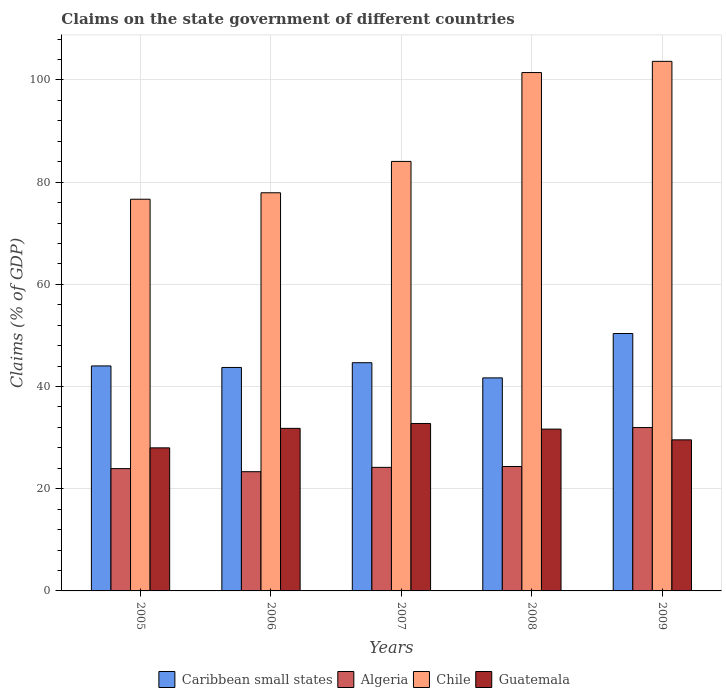How many different coloured bars are there?
Give a very brief answer. 4. How many groups of bars are there?
Your response must be concise. 5. How many bars are there on the 3rd tick from the left?
Your answer should be very brief. 4. How many bars are there on the 2nd tick from the right?
Keep it short and to the point. 4. In how many cases, is the number of bars for a given year not equal to the number of legend labels?
Provide a succinct answer. 0. What is the percentage of GDP claimed on the state government in Guatemala in 2006?
Provide a succinct answer. 31.82. Across all years, what is the maximum percentage of GDP claimed on the state government in Caribbean small states?
Offer a very short reply. 50.38. Across all years, what is the minimum percentage of GDP claimed on the state government in Caribbean small states?
Provide a short and direct response. 41.7. In which year was the percentage of GDP claimed on the state government in Caribbean small states maximum?
Offer a terse response. 2009. What is the total percentage of GDP claimed on the state government in Chile in the graph?
Offer a very short reply. 443.74. What is the difference between the percentage of GDP claimed on the state government in Guatemala in 2006 and that in 2008?
Provide a short and direct response. 0.15. What is the difference between the percentage of GDP claimed on the state government in Algeria in 2007 and the percentage of GDP claimed on the state government in Chile in 2009?
Your answer should be very brief. -79.46. What is the average percentage of GDP claimed on the state government in Chile per year?
Offer a very short reply. 88.75. In the year 2008, what is the difference between the percentage of GDP claimed on the state government in Caribbean small states and percentage of GDP claimed on the state government in Algeria?
Your response must be concise. 17.34. What is the ratio of the percentage of GDP claimed on the state government in Algeria in 2008 to that in 2009?
Your response must be concise. 0.76. Is the difference between the percentage of GDP claimed on the state government in Caribbean small states in 2005 and 2006 greater than the difference between the percentage of GDP claimed on the state government in Algeria in 2005 and 2006?
Make the answer very short. No. What is the difference between the highest and the second highest percentage of GDP claimed on the state government in Chile?
Keep it short and to the point. 2.19. What is the difference between the highest and the lowest percentage of GDP claimed on the state government in Chile?
Keep it short and to the point. 26.98. Is the sum of the percentage of GDP claimed on the state government in Guatemala in 2006 and 2008 greater than the maximum percentage of GDP claimed on the state government in Chile across all years?
Your answer should be compact. No. Is it the case that in every year, the sum of the percentage of GDP claimed on the state government in Guatemala and percentage of GDP claimed on the state government in Caribbean small states is greater than the sum of percentage of GDP claimed on the state government in Algeria and percentage of GDP claimed on the state government in Chile?
Offer a terse response. Yes. What does the 4th bar from the left in 2007 represents?
Give a very brief answer. Guatemala. What does the 2nd bar from the right in 2009 represents?
Your response must be concise. Chile. How many bars are there?
Provide a succinct answer. 20. Are all the bars in the graph horizontal?
Keep it short and to the point. No. Are the values on the major ticks of Y-axis written in scientific E-notation?
Ensure brevity in your answer.  No. Does the graph contain any zero values?
Make the answer very short. No. What is the title of the graph?
Give a very brief answer. Claims on the state government of different countries. Does "Cayman Islands" appear as one of the legend labels in the graph?
Give a very brief answer. No. What is the label or title of the Y-axis?
Make the answer very short. Claims (% of GDP). What is the Claims (% of GDP) of Caribbean small states in 2005?
Keep it short and to the point. 44.03. What is the Claims (% of GDP) of Algeria in 2005?
Your answer should be very brief. 23.94. What is the Claims (% of GDP) in Chile in 2005?
Make the answer very short. 76.66. What is the Claims (% of GDP) of Guatemala in 2005?
Keep it short and to the point. 28. What is the Claims (% of GDP) of Caribbean small states in 2006?
Make the answer very short. 43.73. What is the Claims (% of GDP) in Algeria in 2006?
Offer a very short reply. 23.33. What is the Claims (% of GDP) of Chile in 2006?
Your answer should be very brief. 77.92. What is the Claims (% of GDP) in Guatemala in 2006?
Your response must be concise. 31.82. What is the Claims (% of GDP) of Caribbean small states in 2007?
Your response must be concise. 44.67. What is the Claims (% of GDP) of Algeria in 2007?
Your answer should be very brief. 24.18. What is the Claims (% of GDP) of Chile in 2007?
Give a very brief answer. 84.06. What is the Claims (% of GDP) in Guatemala in 2007?
Make the answer very short. 32.77. What is the Claims (% of GDP) of Caribbean small states in 2008?
Make the answer very short. 41.7. What is the Claims (% of GDP) in Algeria in 2008?
Your response must be concise. 24.35. What is the Claims (% of GDP) in Chile in 2008?
Make the answer very short. 101.45. What is the Claims (% of GDP) in Guatemala in 2008?
Offer a very short reply. 31.67. What is the Claims (% of GDP) in Caribbean small states in 2009?
Ensure brevity in your answer.  50.38. What is the Claims (% of GDP) in Algeria in 2009?
Offer a very short reply. 31.97. What is the Claims (% of GDP) in Chile in 2009?
Keep it short and to the point. 103.65. What is the Claims (% of GDP) in Guatemala in 2009?
Your response must be concise. 29.57. Across all years, what is the maximum Claims (% of GDP) of Caribbean small states?
Offer a terse response. 50.38. Across all years, what is the maximum Claims (% of GDP) of Algeria?
Offer a very short reply. 31.97. Across all years, what is the maximum Claims (% of GDP) in Chile?
Give a very brief answer. 103.65. Across all years, what is the maximum Claims (% of GDP) in Guatemala?
Offer a terse response. 32.77. Across all years, what is the minimum Claims (% of GDP) in Caribbean small states?
Give a very brief answer. 41.7. Across all years, what is the minimum Claims (% of GDP) of Algeria?
Provide a short and direct response. 23.33. Across all years, what is the minimum Claims (% of GDP) of Chile?
Make the answer very short. 76.66. Across all years, what is the minimum Claims (% of GDP) of Guatemala?
Offer a very short reply. 28. What is the total Claims (% of GDP) of Caribbean small states in the graph?
Your answer should be very brief. 224.5. What is the total Claims (% of GDP) of Algeria in the graph?
Give a very brief answer. 127.78. What is the total Claims (% of GDP) in Chile in the graph?
Your response must be concise. 443.74. What is the total Claims (% of GDP) in Guatemala in the graph?
Keep it short and to the point. 153.83. What is the difference between the Claims (% of GDP) of Caribbean small states in 2005 and that in 2006?
Your answer should be compact. 0.3. What is the difference between the Claims (% of GDP) in Algeria in 2005 and that in 2006?
Provide a short and direct response. 0.6. What is the difference between the Claims (% of GDP) in Chile in 2005 and that in 2006?
Offer a very short reply. -1.26. What is the difference between the Claims (% of GDP) of Guatemala in 2005 and that in 2006?
Your response must be concise. -3.82. What is the difference between the Claims (% of GDP) in Caribbean small states in 2005 and that in 2007?
Ensure brevity in your answer.  -0.63. What is the difference between the Claims (% of GDP) of Algeria in 2005 and that in 2007?
Provide a succinct answer. -0.24. What is the difference between the Claims (% of GDP) in Chile in 2005 and that in 2007?
Offer a terse response. -7.4. What is the difference between the Claims (% of GDP) of Guatemala in 2005 and that in 2007?
Give a very brief answer. -4.77. What is the difference between the Claims (% of GDP) in Caribbean small states in 2005 and that in 2008?
Keep it short and to the point. 2.34. What is the difference between the Claims (% of GDP) of Algeria in 2005 and that in 2008?
Your answer should be very brief. -0.41. What is the difference between the Claims (% of GDP) of Chile in 2005 and that in 2008?
Ensure brevity in your answer.  -24.79. What is the difference between the Claims (% of GDP) of Guatemala in 2005 and that in 2008?
Make the answer very short. -3.67. What is the difference between the Claims (% of GDP) in Caribbean small states in 2005 and that in 2009?
Keep it short and to the point. -6.34. What is the difference between the Claims (% of GDP) of Algeria in 2005 and that in 2009?
Give a very brief answer. -8.03. What is the difference between the Claims (% of GDP) in Chile in 2005 and that in 2009?
Your response must be concise. -26.98. What is the difference between the Claims (% of GDP) in Guatemala in 2005 and that in 2009?
Offer a very short reply. -1.57. What is the difference between the Claims (% of GDP) in Caribbean small states in 2006 and that in 2007?
Offer a very short reply. -0.93. What is the difference between the Claims (% of GDP) in Algeria in 2006 and that in 2007?
Ensure brevity in your answer.  -0.85. What is the difference between the Claims (% of GDP) of Chile in 2006 and that in 2007?
Your answer should be very brief. -6.14. What is the difference between the Claims (% of GDP) in Guatemala in 2006 and that in 2007?
Make the answer very short. -0.95. What is the difference between the Claims (% of GDP) in Caribbean small states in 2006 and that in 2008?
Your answer should be compact. 2.04. What is the difference between the Claims (% of GDP) of Algeria in 2006 and that in 2008?
Your answer should be very brief. -1.02. What is the difference between the Claims (% of GDP) in Chile in 2006 and that in 2008?
Offer a terse response. -23.53. What is the difference between the Claims (% of GDP) in Guatemala in 2006 and that in 2008?
Keep it short and to the point. 0.15. What is the difference between the Claims (% of GDP) in Caribbean small states in 2006 and that in 2009?
Ensure brevity in your answer.  -6.64. What is the difference between the Claims (% of GDP) in Algeria in 2006 and that in 2009?
Provide a succinct answer. -8.64. What is the difference between the Claims (% of GDP) of Chile in 2006 and that in 2009?
Give a very brief answer. -25.72. What is the difference between the Claims (% of GDP) in Guatemala in 2006 and that in 2009?
Your answer should be compact. 2.25. What is the difference between the Claims (% of GDP) in Caribbean small states in 2007 and that in 2008?
Give a very brief answer. 2.97. What is the difference between the Claims (% of GDP) of Algeria in 2007 and that in 2008?
Provide a succinct answer. -0.17. What is the difference between the Claims (% of GDP) in Chile in 2007 and that in 2008?
Give a very brief answer. -17.39. What is the difference between the Claims (% of GDP) of Guatemala in 2007 and that in 2008?
Provide a succinct answer. 1.1. What is the difference between the Claims (% of GDP) in Caribbean small states in 2007 and that in 2009?
Your answer should be very brief. -5.71. What is the difference between the Claims (% of GDP) in Algeria in 2007 and that in 2009?
Your answer should be compact. -7.79. What is the difference between the Claims (% of GDP) in Chile in 2007 and that in 2009?
Keep it short and to the point. -19.58. What is the difference between the Claims (% of GDP) in Guatemala in 2007 and that in 2009?
Offer a terse response. 3.2. What is the difference between the Claims (% of GDP) of Caribbean small states in 2008 and that in 2009?
Your answer should be compact. -8.68. What is the difference between the Claims (% of GDP) in Algeria in 2008 and that in 2009?
Your answer should be compact. -7.62. What is the difference between the Claims (% of GDP) of Chile in 2008 and that in 2009?
Provide a short and direct response. -2.19. What is the difference between the Claims (% of GDP) of Guatemala in 2008 and that in 2009?
Your answer should be very brief. 2.11. What is the difference between the Claims (% of GDP) of Caribbean small states in 2005 and the Claims (% of GDP) of Algeria in 2006?
Provide a succinct answer. 20.7. What is the difference between the Claims (% of GDP) of Caribbean small states in 2005 and the Claims (% of GDP) of Chile in 2006?
Offer a terse response. -33.89. What is the difference between the Claims (% of GDP) in Caribbean small states in 2005 and the Claims (% of GDP) in Guatemala in 2006?
Ensure brevity in your answer.  12.21. What is the difference between the Claims (% of GDP) in Algeria in 2005 and the Claims (% of GDP) in Chile in 2006?
Provide a succinct answer. -53.98. What is the difference between the Claims (% of GDP) in Algeria in 2005 and the Claims (% of GDP) in Guatemala in 2006?
Offer a terse response. -7.88. What is the difference between the Claims (% of GDP) of Chile in 2005 and the Claims (% of GDP) of Guatemala in 2006?
Provide a short and direct response. 44.84. What is the difference between the Claims (% of GDP) of Caribbean small states in 2005 and the Claims (% of GDP) of Algeria in 2007?
Your response must be concise. 19.85. What is the difference between the Claims (% of GDP) in Caribbean small states in 2005 and the Claims (% of GDP) in Chile in 2007?
Offer a terse response. -40.03. What is the difference between the Claims (% of GDP) in Caribbean small states in 2005 and the Claims (% of GDP) in Guatemala in 2007?
Make the answer very short. 11.26. What is the difference between the Claims (% of GDP) of Algeria in 2005 and the Claims (% of GDP) of Chile in 2007?
Your answer should be compact. -60.12. What is the difference between the Claims (% of GDP) in Algeria in 2005 and the Claims (% of GDP) in Guatemala in 2007?
Your answer should be compact. -8.83. What is the difference between the Claims (% of GDP) in Chile in 2005 and the Claims (% of GDP) in Guatemala in 2007?
Make the answer very short. 43.89. What is the difference between the Claims (% of GDP) of Caribbean small states in 2005 and the Claims (% of GDP) of Algeria in 2008?
Keep it short and to the point. 19.68. What is the difference between the Claims (% of GDP) in Caribbean small states in 2005 and the Claims (% of GDP) in Chile in 2008?
Provide a succinct answer. -57.42. What is the difference between the Claims (% of GDP) in Caribbean small states in 2005 and the Claims (% of GDP) in Guatemala in 2008?
Offer a very short reply. 12.36. What is the difference between the Claims (% of GDP) of Algeria in 2005 and the Claims (% of GDP) of Chile in 2008?
Your answer should be compact. -77.51. What is the difference between the Claims (% of GDP) in Algeria in 2005 and the Claims (% of GDP) in Guatemala in 2008?
Ensure brevity in your answer.  -7.73. What is the difference between the Claims (% of GDP) in Chile in 2005 and the Claims (% of GDP) in Guatemala in 2008?
Provide a succinct answer. 44.99. What is the difference between the Claims (% of GDP) of Caribbean small states in 2005 and the Claims (% of GDP) of Algeria in 2009?
Ensure brevity in your answer.  12.06. What is the difference between the Claims (% of GDP) in Caribbean small states in 2005 and the Claims (% of GDP) in Chile in 2009?
Ensure brevity in your answer.  -59.61. What is the difference between the Claims (% of GDP) in Caribbean small states in 2005 and the Claims (% of GDP) in Guatemala in 2009?
Offer a terse response. 14.47. What is the difference between the Claims (% of GDP) in Algeria in 2005 and the Claims (% of GDP) in Chile in 2009?
Offer a terse response. -79.71. What is the difference between the Claims (% of GDP) in Algeria in 2005 and the Claims (% of GDP) in Guatemala in 2009?
Your response must be concise. -5.63. What is the difference between the Claims (% of GDP) in Chile in 2005 and the Claims (% of GDP) in Guatemala in 2009?
Ensure brevity in your answer.  47.1. What is the difference between the Claims (% of GDP) of Caribbean small states in 2006 and the Claims (% of GDP) of Algeria in 2007?
Offer a terse response. 19.55. What is the difference between the Claims (% of GDP) of Caribbean small states in 2006 and the Claims (% of GDP) of Chile in 2007?
Provide a succinct answer. -40.33. What is the difference between the Claims (% of GDP) in Caribbean small states in 2006 and the Claims (% of GDP) in Guatemala in 2007?
Offer a very short reply. 10.96. What is the difference between the Claims (% of GDP) in Algeria in 2006 and the Claims (% of GDP) in Chile in 2007?
Your response must be concise. -60.73. What is the difference between the Claims (% of GDP) of Algeria in 2006 and the Claims (% of GDP) of Guatemala in 2007?
Ensure brevity in your answer.  -9.44. What is the difference between the Claims (% of GDP) in Chile in 2006 and the Claims (% of GDP) in Guatemala in 2007?
Your response must be concise. 45.15. What is the difference between the Claims (% of GDP) in Caribbean small states in 2006 and the Claims (% of GDP) in Algeria in 2008?
Provide a succinct answer. 19.38. What is the difference between the Claims (% of GDP) in Caribbean small states in 2006 and the Claims (% of GDP) in Chile in 2008?
Your answer should be compact. -57.72. What is the difference between the Claims (% of GDP) in Caribbean small states in 2006 and the Claims (% of GDP) in Guatemala in 2008?
Keep it short and to the point. 12.06. What is the difference between the Claims (% of GDP) of Algeria in 2006 and the Claims (% of GDP) of Chile in 2008?
Provide a short and direct response. -78.12. What is the difference between the Claims (% of GDP) of Algeria in 2006 and the Claims (% of GDP) of Guatemala in 2008?
Offer a very short reply. -8.34. What is the difference between the Claims (% of GDP) of Chile in 2006 and the Claims (% of GDP) of Guatemala in 2008?
Offer a terse response. 46.25. What is the difference between the Claims (% of GDP) of Caribbean small states in 2006 and the Claims (% of GDP) of Algeria in 2009?
Make the answer very short. 11.76. What is the difference between the Claims (% of GDP) of Caribbean small states in 2006 and the Claims (% of GDP) of Chile in 2009?
Provide a succinct answer. -59.91. What is the difference between the Claims (% of GDP) of Caribbean small states in 2006 and the Claims (% of GDP) of Guatemala in 2009?
Your answer should be compact. 14.17. What is the difference between the Claims (% of GDP) of Algeria in 2006 and the Claims (% of GDP) of Chile in 2009?
Your response must be concise. -80.31. What is the difference between the Claims (% of GDP) in Algeria in 2006 and the Claims (% of GDP) in Guatemala in 2009?
Make the answer very short. -6.23. What is the difference between the Claims (% of GDP) in Chile in 2006 and the Claims (% of GDP) in Guatemala in 2009?
Offer a terse response. 48.36. What is the difference between the Claims (% of GDP) of Caribbean small states in 2007 and the Claims (% of GDP) of Algeria in 2008?
Your answer should be compact. 20.31. What is the difference between the Claims (% of GDP) in Caribbean small states in 2007 and the Claims (% of GDP) in Chile in 2008?
Your answer should be compact. -56.79. What is the difference between the Claims (% of GDP) in Caribbean small states in 2007 and the Claims (% of GDP) in Guatemala in 2008?
Provide a short and direct response. 12.99. What is the difference between the Claims (% of GDP) of Algeria in 2007 and the Claims (% of GDP) of Chile in 2008?
Your answer should be very brief. -77.27. What is the difference between the Claims (% of GDP) in Algeria in 2007 and the Claims (% of GDP) in Guatemala in 2008?
Ensure brevity in your answer.  -7.49. What is the difference between the Claims (% of GDP) in Chile in 2007 and the Claims (% of GDP) in Guatemala in 2008?
Provide a short and direct response. 52.39. What is the difference between the Claims (% of GDP) in Caribbean small states in 2007 and the Claims (% of GDP) in Algeria in 2009?
Offer a terse response. 12.69. What is the difference between the Claims (% of GDP) of Caribbean small states in 2007 and the Claims (% of GDP) of Chile in 2009?
Provide a succinct answer. -58.98. What is the difference between the Claims (% of GDP) in Caribbean small states in 2007 and the Claims (% of GDP) in Guatemala in 2009?
Provide a short and direct response. 15.1. What is the difference between the Claims (% of GDP) of Algeria in 2007 and the Claims (% of GDP) of Chile in 2009?
Provide a succinct answer. -79.46. What is the difference between the Claims (% of GDP) in Algeria in 2007 and the Claims (% of GDP) in Guatemala in 2009?
Provide a short and direct response. -5.39. What is the difference between the Claims (% of GDP) of Chile in 2007 and the Claims (% of GDP) of Guatemala in 2009?
Offer a terse response. 54.49. What is the difference between the Claims (% of GDP) in Caribbean small states in 2008 and the Claims (% of GDP) in Algeria in 2009?
Ensure brevity in your answer.  9.72. What is the difference between the Claims (% of GDP) of Caribbean small states in 2008 and the Claims (% of GDP) of Chile in 2009?
Give a very brief answer. -61.95. What is the difference between the Claims (% of GDP) in Caribbean small states in 2008 and the Claims (% of GDP) in Guatemala in 2009?
Your answer should be compact. 12.13. What is the difference between the Claims (% of GDP) in Algeria in 2008 and the Claims (% of GDP) in Chile in 2009?
Keep it short and to the point. -79.29. What is the difference between the Claims (% of GDP) of Algeria in 2008 and the Claims (% of GDP) of Guatemala in 2009?
Provide a succinct answer. -5.21. What is the difference between the Claims (% of GDP) of Chile in 2008 and the Claims (% of GDP) of Guatemala in 2009?
Give a very brief answer. 71.89. What is the average Claims (% of GDP) in Caribbean small states per year?
Provide a succinct answer. 44.9. What is the average Claims (% of GDP) in Algeria per year?
Make the answer very short. 25.56. What is the average Claims (% of GDP) of Chile per year?
Offer a terse response. 88.75. What is the average Claims (% of GDP) of Guatemala per year?
Ensure brevity in your answer.  30.77. In the year 2005, what is the difference between the Claims (% of GDP) in Caribbean small states and Claims (% of GDP) in Algeria?
Your answer should be very brief. 20.1. In the year 2005, what is the difference between the Claims (% of GDP) of Caribbean small states and Claims (% of GDP) of Chile?
Your answer should be very brief. -32.63. In the year 2005, what is the difference between the Claims (% of GDP) of Caribbean small states and Claims (% of GDP) of Guatemala?
Offer a terse response. 16.03. In the year 2005, what is the difference between the Claims (% of GDP) of Algeria and Claims (% of GDP) of Chile?
Your answer should be very brief. -52.72. In the year 2005, what is the difference between the Claims (% of GDP) of Algeria and Claims (% of GDP) of Guatemala?
Your response must be concise. -4.06. In the year 2005, what is the difference between the Claims (% of GDP) of Chile and Claims (% of GDP) of Guatemala?
Offer a very short reply. 48.66. In the year 2006, what is the difference between the Claims (% of GDP) of Caribbean small states and Claims (% of GDP) of Algeria?
Make the answer very short. 20.4. In the year 2006, what is the difference between the Claims (% of GDP) of Caribbean small states and Claims (% of GDP) of Chile?
Keep it short and to the point. -34.19. In the year 2006, what is the difference between the Claims (% of GDP) in Caribbean small states and Claims (% of GDP) in Guatemala?
Keep it short and to the point. 11.91. In the year 2006, what is the difference between the Claims (% of GDP) of Algeria and Claims (% of GDP) of Chile?
Give a very brief answer. -54.59. In the year 2006, what is the difference between the Claims (% of GDP) of Algeria and Claims (% of GDP) of Guatemala?
Offer a very short reply. -8.48. In the year 2006, what is the difference between the Claims (% of GDP) in Chile and Claims (% of GDP) in Guatemala?
Make the answer very short. 46.1. In the year 2007, what is the difference between the Claims (% of GDP) of Caribbean small states and Claims (% of GDP) of Algeria?
Your response must be concise. 20.48. In the year 2007, what is the difference between the Claims (% of GDP) in Caribbean small states and Claims (% of GDP) in Chile?
Your answer should be very brief. -39.4. In the year 2007, what is the difference between the Claims (% of GDP) in Caribbean small states and Claims (% of GDP) in Guatemala?
Make the answer very short. 11.89. In the year 2007, what is the difference between the Claims (% of GDP) of Algeria and Claims (% of GDP) of Chile?
Ensure brevity in your answer.  -59.88. In the year 2007, what is the difference between the Claims (% of GDP) of Algeria and Claims (% of GDP) of Guatemala?
Offer a very short reply. -8.59. In the year 2007, what is the difference between the Claims (% of GDP) of Chile and Claims (% of GDP) of Guatemala?
Your answer should be compact. 51.29. In the year 2008, what is the difference between the Claims (% of GDP) of Caribbean small states and Claims (% of GDP) of Algeria?
Provide a succinct answer. 17.34. In the year 2008, what is the difference between the Claims (% of GDP) of Caribbean small states and Claims (% of GDP) of Chile?
Your answer should be compact. -59.76. In the year 2008, what is the difference between the Claims (% of GDP) of Caribbean small states and Claims (% of GDP) of Guatemala?
Offer a terse response. 10.02. In the year 2008, what is the difference between the Claims (% of GDP) of Algeria and Claims (% of GDP) of Chile?
Make the answer very short. -77.1. In the year 2008, what is the difference between the Claims (% of GDP) in Algeria and Claims (% of GDP) in Guatemala?
Ensure brevity in your answer.  -7.32. In the year 2008, what is the difference between the Claims (% of GDP) in Chile and Claims (% of GDP) in Guatemala?
Your response must be concise. 69.78. In the year 2009, what is the difference between the Claims (% of GDP) of Caribbean small states and Claims (% of GDP) of Algeria?
Offer a terse response. 18.4. In the year 2009, what is the difference between the Claims (% of GDP) in Caribbean small states and Claims (% of GDP) in Chile?
Offer a terse response. -53.27. In the year 2009, what is the difference between the Claims (% of GDP) of Caribbean small states and Claims (% of GDP) of Guatemala?
Give a very brief answer. 20.81. In the year 2009, what is the difference between the Claims (% of GDP) of Algeria and Claims (% of GDP) of Chile?
Provide a succinct answer. -71.67. In the year 2009, what is the difference between the Claims (% of GDP) in Algeria and Claims (% of GDP) in Guatemala?
Give a very brief answer. 2.41. In the year 2009, what is the difference between the Claims (% of GDP) of Chile and Claims (% of GDP) of Guatemala?
Give a very brief answer. 74.08. What is the ratio of the Claims (% of GDP) of Caribbean small states in 2005 to that in 2006?
Offer a very short reply. 1.01. What is the ratio of the Claims (% of GDP) in Algeria in 2005 to that in 2006?
Give a very brief answer. 1.03. What is the ratio of the Claims (% of GDP) of Chile in 2005 to that in 2006?
Provide a succinct answer. 0.98. What is the ratio of the Claims (% of GDP) in Caribbean small states in 2005 to that in 2007?
Your answer should be very brief. 0.99. What is the ratio of the Claims (% of GDP) in Chile in 2005 to that in 2007?
Give a very brief answer. 0.91. What is the ratio of the Claims (% of GDP) in Guatemala in 2005 to that in 2007?
Ensure brevity in your answer.  0.85. What is the ratio of the Claims (% of GDP) of Caribbean small states in 2005 to that in 2008?
Keep it short and to the point. 1.06. What is the ratio of the Claims (% of GDP) in Algeria in 2005 to that in 2008?
Keep it short and to the point. 0.98. What is the ratio of the Claims (% of GDP) in Chile in 2005 to that in 2008?
Provide a short and direct response. 0.76. What is the ratio of the Claims (% of GDP) of Guatemala in 2005 to that in 2008?
Offer a terse response. 0.88. What is the ratio of the Claims (% of GDP) of Caribbean small states in 2005 to that in 2009?
Offer a terse response. 0.87. What is the ratio of the Claims (% of GDP) of Algeria in 2005 to that in 2009?
Your answer should be compact. 0.75. What is the ratio of the Claims (% of GDP) in Chile in 2005 to that in 2009?
Ensure brevity in your answer.  0.74. What is the ratio of the Claims (% of GDP) in Guatemala in 2005 to that in 2009?
Provide a short and direct response. 0.95. What is the ratio of the Claims (% of GDP) in Caribbean small states in 2006 to that in 2007?
Make the answer very short. 0.98. What is the ratio of the Claims (% of GDP) in Chile in 2006 to that in 2007?
Your answer should be compact. 0.93. What is the ratio of the Claims (% of GDP) of Guatemala in 2006 to that in 2007?
Your response must be concise. 0.97. What is the ratio of the Claims (% of GDP) in Caribbean small states in 2006 to that in 2008?
Provide a short and direct response. 1.05. What is the ratio of the Claims (% of GDP) in Algeria in 2006 to that in 2008?
Offer a very short reply. 0.96. What is the ratio of the Claims (% of GDP) in Chile in 2006 to that in 2008?
Your answer should be very brief. 0.77. What is the ratio of the Claims (% of GDP) of Guatemala in 2006 to that in 2008?
Keep it short and to the point. 1. What is the ratio of the Claims (% of GDP) in Caribbean small states in 2006 to that in 2009?
Give a very brief answer. 0.87. What is the ratio of the Claims (% of GDP) of Algeria in 2006 to that in 2009?
Make the answer very short. 0.73. What is the ratio of the Claims (% of GDP) in Chile in 2006 to that in 2009?
Offer a very short reply. 0.75. What is the ratio of the Claims (% of GDP) in Guatemala in 2006 to that in 2009?
Make the answer very short. 1.08. What is the ratio of the Claims (% of GDP) of Caribbean small states in 2007 to that in 2008?
Give a very brief answer. 1.07. What is the ratio of the Claims (% of GDP) of Algeria in 2007 to that in 2008?
Offer a very short reply. 0.99. What is the ratio of the Claims (% of GDP) in Chile in 2007 to that in 2008?
Make the answer very short. 0.83. What is the ratio of the Claims (% of GDP) in Guatemala in 2007 to that in 2008?
Your response must be concise. 1.03. What is the ratio of the Claims (% of GDP) of Caribbean small states in 2007 to that in 2009?
Provide a short and direct response. 0.89. What is the ratio of the Claims (% of GDP) of Algeria in 2007 to that in 2009?
Your answer should be compact. 0.76. What is the ratio of the Claims (% of GDP) of Chile in 2007 to that in 2009?
Provide a succinct answer. 0.81. What is the ratio of the Claims (% of GDP) in Guatemala in 2007 to that in 2009?
Provide a succinct answer. 1.11. What is the ratio of the Claims (% of GDP) of Caribbean small states in 2008 to that in 2009?
Provide a short and direct response. 0.83. What is the ratio of the Claims (% of GDP) of Algeria in 2008 to that in 2009?
Provide a succinct answer. 0.76. What is the ratio of the Claims (% of GDP) of Chile in 2008 to that in 2009?
Offer a very short reply. 0.98. What is the ratio of the Claims (% of GDP) in Guatemala in 2008 to that in 2009?
Your answer should be compact. 1.07. What is the difference between the highest and the second highest Claims (% of GDP) of Caribbean small states?
Make the answer very short. 5.71. What is the difference between the highest and the second highest Claims (% of GDP) of Algeria?
Your answer should be compact. 7.62. What is the difference between the highest and the second highest Claims (% of GDP) of Chile?
Give a very brief answer. 2.19. What is the difference between the highest and the second highest Claims (% of GDP) in Guatemala?
Keep it short and to the point. 0.95. What is the difference between the highest and the lowest Claims (% of GDP) in Caribbean small states?
Keep it short and to the point. 8.68. What is the difference between the highest and the lowest Claims (% of GDP) in Algeria?
Keep it short and to the point. 8.64. What is the difference between the highest and the lowest Claims (% of GDP) of Chile?
Your answer should be compact. 26.98. What is the difference between the highest and the lowest Claims (% of GDP) of Guatemala?
Offer a very short reply. 4.77. 